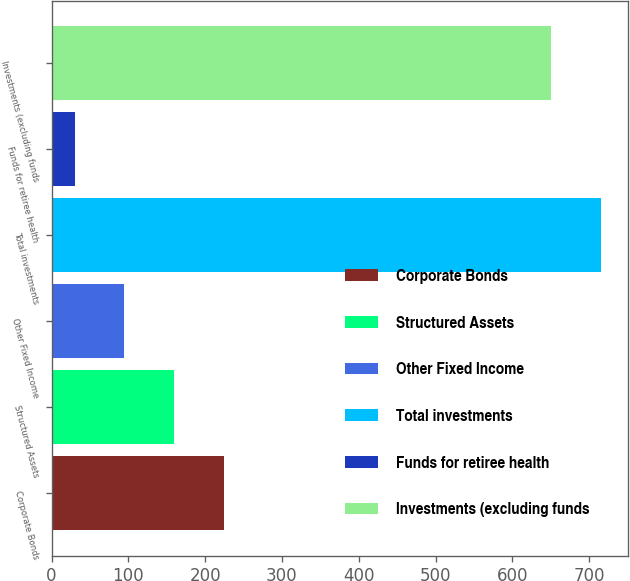Convert chart. <chart><loc_0><loc_0><loc_500><loc_500><bar_chart><fcel>Corporate Bonds<fcel>Structured Assets<fcel>Other Fixed Income<fcel>Total investments<fcel>Funds for retiree health<fcel>Investments (excluding funds<nl><fcel>225<fcel>160<fcel>95<fcel>715<fcel>30<fcel>650<nl></chart> 